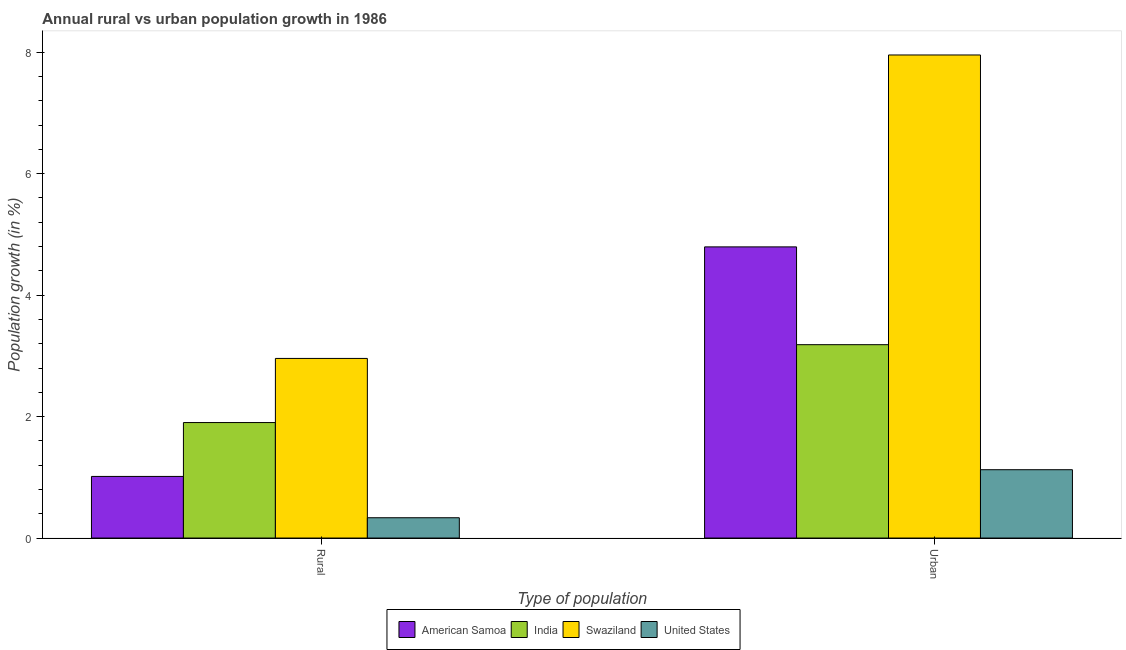How many groups of bars are there?
Your answer should be compact. 2. Are the number of bars per tick equal to the number of legend labels?
Give a very brief answer. Yes. What is the label of the 1st group of bars from the left?
Your answer should be very brief. Rural. What is the rural population growth in United States?
Provide a short and direct response. 0.33. Across all countries, what is the maximum urban population growth?
Provide a short and direct response. 7.96. Across all countries, what is the minimum rural population growth?
Keep it short and to the point. 0.33. In which country was the urban population growth maximum?
Offer a terse response. Swaziland. In which country was the urban population growth minimum?
Make the answer very short. United States. What is the total rural population growth in the graph?
Provide a succinct answer. 6.21. What is the difference between the rural population growth in Swaziland and that in United States?
Ensure brevity in your answer.  2.62. What is the difference between the rural population growth in American Samoa and the urban population growth in United States?
Offer a very short reply. -0.11. What is the average rural population growth per country?
Offer a very short reply. 1.55. What is the difference between the urban population growth and rural population growth in American Samoa?
Ensure brevity in your answer.  3.78. In how many countries, is the urban population growth greater than 4.8 %?
Offer a very short reply. 1. What is the ratio of the rural population growth in India to that in Swaziland?
Make the answer very short. 0.64. In how many countries, is the rural population growth greater than the average rural population growth taken over all countries?
Your response must be concise. 2. What does the 2nd bar from the left in Urban  represents?
Offer a terse response. India. What does the 4th bar from the right in Rural represents?
Provide a short and direct response. American Samoa. How many bars are there?
Your response must be concise. 8. Are all the bars in the graph horizontal?
Your response must be concise. No. What is the difference between two consecutive major ticks on the Y-axis?
Provide a succinct answer. 2. Does the graph contain any zero values?
Give a very brief answer. No. How are the legend labels stacked?
Your response must be concise. Horizontal. What is the title of the graph?
Provide a short and direct response. Annual rural vs urban population growth in 1986. Does "High income: OECD" appear as one of the legend labels in the graph?
Provide a succinct answer. No. What is the label or title of the X-axis?
Offer a very short reply. Type of population. What is the label or title of the Y-axis?
Your answer should be compact. Population growth (in %). What is the Population growth (in %) of American Samoa in Rural?
Keep it short and to the point. 1.01. What is the Population growth (in %) of India in Rural?
Offer a terse response. 1.9. What is the Population growth (in %) of Swaziland in Rural?
Provide a short and direct response. 2.96. What is the Population growth (in %) of United States in Rural?
Offer a very short reply. 0.33. What is the Population growth (in %) in American Samoa in Urban ?
Your answer should be compact. 4.79. What is the Population growth (in %) in India in Urban ?
Your response must be concise. 3.18. What is the Population growth (in %) in Swaziland in Urban ?
Give a very brief answer. 7.96. What is the Population growth (in %) of United States in Urban ?
Your answer should be compact. 1.13. Across all Type of population, what is the maximum Population growth (in %) in American Samoa?
Ensure brevity in your answer.  4.79. Across all Type of population, what is the maximum Population growth (in %) in India?
Offer a terse response. 3.18. Across all Type of population, what is the maximum Population growth (in %) in Swaziland?
Ensure brevity in your answer.  7.96. Across all Type of population, what is the maximum Population growth (in %) of United States?
Keep it short and to the point. 1.13. Across all Type of population, what is the minimum Population growth (in %) of American Samoa?
Provide a succinct answer. 1.01. Across all Type of population, what is the minimum Population growth (in %) of India?
Offer a terse response. 1.9. Across all Type of population, what is the minimum Population growth (in %) of Swaziland?
Give a very brief answer. 2.96. Across all Type of population, what is the minimum Population growth (in %) in United States?
Your answer should be compact. 0.33. What is the total Population growth (in %) in American Samoa in the graph?
Keep it short and to the point. 5.81. What is the total Population growth (in %) of India in the graph?
Your answer should be very brief. 5.09. What is the total Population growth (in %) in Swaziland in the graph?
Offer a terse response. 10.91. What is the total Population growth (in %) in United States in the graph?
Offer a terse response. 1.46. What is the difference between the Population growth (in %) in American Samoa in Rural and that in Urban ?
Keep it short and to the point. -3.78. What is the difference between the Population growth (in %) in India in Rural and that in Urban ?
Your answer should be very brief. -1.28. What is the difference between the Population growth (in %) in Swaziland in Rural and that in Urban ?
Ensure brevity in your answer.  -5. What is the difference between the Population growth (in %) of United States in Rural and that in Urban ?
Provide a succinct answer. -0.79. What is the difference between the Population growth (in %) of American Samoa in Rural and the Population growth (in %) of India in Urban?
Provide a short and direct response. -2.17. What is the difference between the Population growth (in %) of American Samoa in Rural and the Population growth (in %) of Swaziland in Urban?
Offer a very short reply. -6.94. What is the difference between the Population growth (in %) of American Samoa in Rural and the Population growth (in %) of United States in Urban?
Provide a short and direct response. -0.11. What is the difference between the Population growth (in %) in India in Rural and the Population growth (in %) in Swaziland in Urban?
Ensure brevity in your answer.  -6.05. What is the difference between the Population growth (in %) of India in Rural and the Population growth (in %) of United States in Urban?
Give a very brief answer. 0.78. What is the difference between the Population growth (in %) of Swaziland in Rural and the Population growth (in %) of United States in Urban?
Offer a very short reply. 1.83. What is the average Population growth (in %) in American Samoa per Type of population?
Give a very brief answer. 2.9. What is the average Population growth (in %) in India per Type of population?
Your response must be concise. 2.54. What is the average Population growth (in %) of Swaziland per Type of population?
Provide a short and direct response. 5.46. What is the average Population growth (in %) in United States per Type of population?
Your answer should be very brief. 0.73. What is the difference between the Population growth (in %) of American Samoa and Population growth (in %) of India in Rural?
Provide a succinct answer. -0.89. What is the difference between the Population growth (in %) in American Samoa and Population growth (in %) in Swaziland in Rural?
Ensure brevity in your answer.  -1.94. What is the difference between the Population growth (in %) of American Samoa and Population growth (in %) of United States in Rural?
Your answer should be compact. 0.68. What is the difference between the Population growth (in %) of India and Population growth (in %) of Swaziland in Rural?
Ensure brevity in your answer.  -1.06. What is the difference between the Population growth (in %) of India and Population growth (in %) of United States in Rural?
Your answer should be compact. 1.57. What is the difference between the Population growth (in %) of Swaziland and Population growth (in %) of United States in Rural?
Your answer should be very brief. 2.62. What is the difference between the Population growth (in %) in American Samoa and Population growth (in %) in India in Urban ?
Offer a very short reply. 1.61. What is the difference between the Population growth (in %) in American Samoa and Population growth (in %) in Swaziland in Urban ?
Your response must be concise. -3.16. What is the difference between the Population growth (in %) in American Samoa and Population growth (in %) in United States in Urban ?
Ensure brevity in your answer.  3.67. What is the difference between the Population growth (in %) of India and Population growth (in %) of Swaziland in Urban ?
Provide a succinct answer. -4.77. What is the difference between the Population growth (in %) in India and Population growth (in %) in United States in Urban ?
Ensure brevity in your answer.  2.06. What is the difference between the Population growth (in %) of Swaziland and Population growth (in %) of United States in Urban ?
Your answer should be very brief. 6.83. What is the ratio of the Population growth (in %) of American Samoa in Rural to that in Urban ?
Offer a terse response. 0.21. What is the ratio of the Population growth (in %) of India in Rural to that in Urban ?
Your answer should be compact. 0.6. What is the ratio of the Population growth (in %) of Swaziland in Rural to that in Urban ?
Your answer should be compact. 0.37. What is the ratio of the Population growth (in %) in United States in Rural to that in Urban ?
Ensure brevity in your answer.  0.3. What is the difference between the highest and the second highest Population growth (in %) of American Samoa?
Provide a short and direct response. 3.78. What is the difference between the highest and the second highest Population growth (in %) in India?
Your response must be concise. 1.28. What is the difference between the highest and the second highest Population growth (in %) in Swaziland?
Your answer should be very brief. 5. What is the difference between the highest and the second highest Population growth (in %) in United States?
Make the answer very short. 0.79. What is the difference between the highest and the lowest Population growth (in %) in American Samoa?
Provide a succinct answer. 3.78. What is the difference between the highest and the lowest Population growth (in %) of India?
Your response must be concise. 1.28. What is the difference between the highest and the lowest Population growth (in %) in Swaziland?
Offer a very short reply. 5. What is the difference between the highest and the lowest Population growth (in %) of United States?
Make the answer very short. 0.79. 